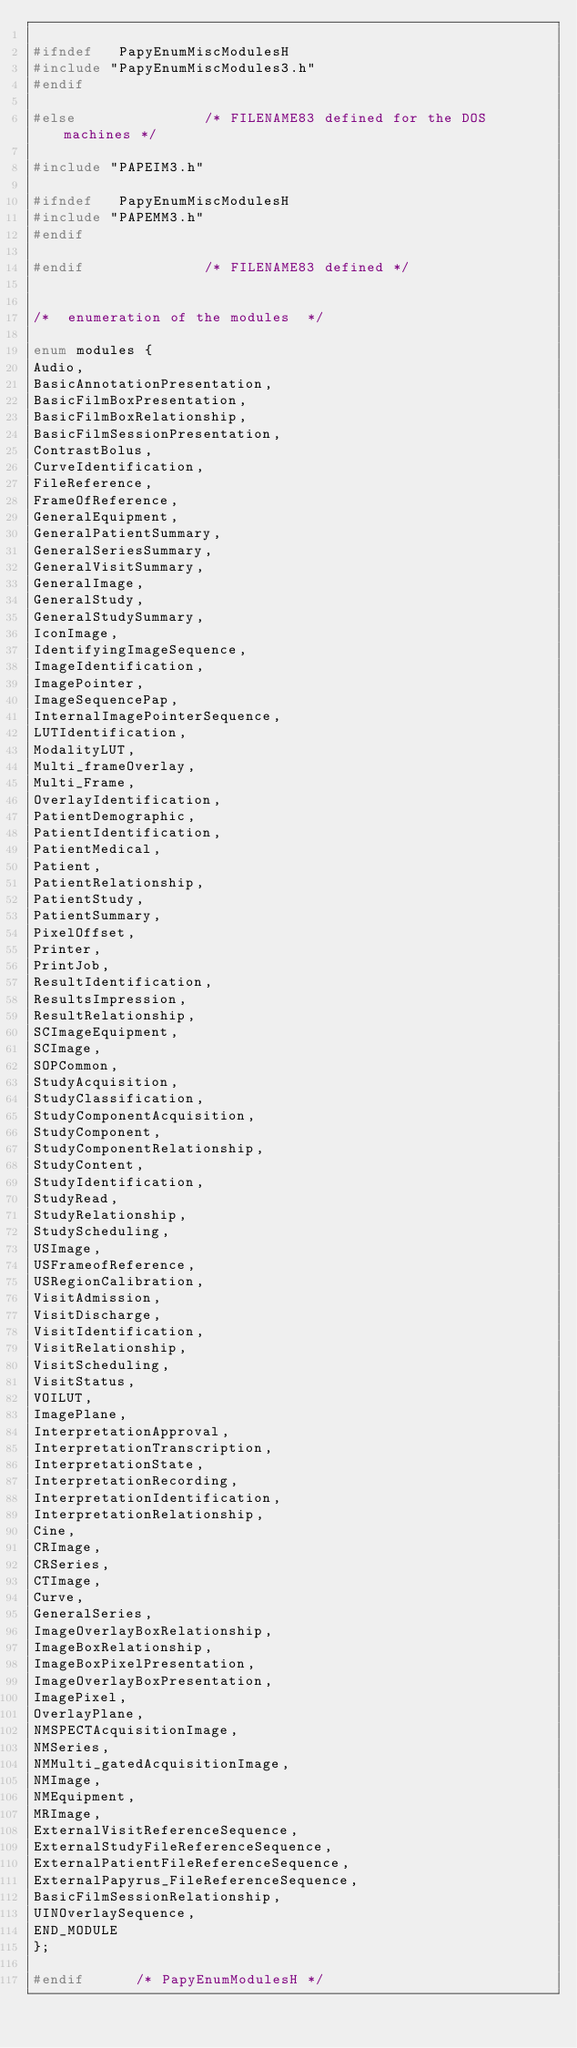Convert code to text. <code><loc_0><loc_0><loc_500><loc_500><_C_>
#ifndef   PapyEnumMiscModulesH
#include "PapyEnumMiscModules3.h"
#endif

#else				/* FILENAME83 defined for the DOS machines */

#include "PAPEIM3.h"

#ifndef   PapyEnumMiscModulesH
#include "PAPEMM3.h"
#endif

#endif 				/* FILENAME83 defined */


/* 	enumeration of the modules	*/

enum modules {
Audio,
BasicAnnotationPresentation,
BasicFilmBoxPresentation,
BasicFilmBoxRelationship,
BasicFilmSessionPresentation,
ContrastBolus,
CurveIdentification,
FileReference,
FrameOfReference,
GeneralEquipment,
GeneralPatientSummary,
GeneralSeriesSummary,
GeneralVisitSummary,
GeneralImage,
GeneralStudy,
GeneralStudySummary,
IconImage,
IdentifyingImageSequence,
ImageIdentification,
ImagePointer,
ImageSequencePap,
InternalImagePointerSequence,
LUTIdentification,
ModalityLUT,
Multi_frameOverlay,
Multi_Frame,
OverlayIdentification,
PatientDemographic,
PatientIdentification,
PatientMedical,
Patient,
PatientRelationship,
PatientStudy,
PatientSummary,
PixelOffset,
Printer,
PrintJob,
ResultIdentification,
ResultsImpression,
ResultRelationship,
SCImageEquipment,
SCImage,
SOPCommon,
StudyAcquisition,
StudyClassification,
StudyComponentAcquisition,
StudyComponent,
StudyComponentRelationship,
StudyContent,
StudyIdentification,
StudyRead,
StudyRelationship,
StudyScheduling,
USImage,
USFrameofReference,
USRegionCalibration,
VisitAdmission,
VisitDischarge,
VisitIdentification,
VisitRelationship,
VisitScheduling,
VisitStatus,
VOILUT,
ImagePlane,
InterpretationApproval,
InterpretationTranscription,
InterpretationState,
InterpretationRecording,
InterpretationIdentification,
InterpretationRelationship,
Cine,
CRImage,
CRSeries,
CTImage,
Curve,
GeneralSeries,
ImageOverlayBoxRelationship,
ImageBoxRelationship,
ImageBoxPixelPresentation,
ImageOverlayBoxPresentation,
ImagePixel,
OverlayPlane,
NMSPECTAcquisitionImage,
NMSeries,
NMMulti_gatedAcquisitionImage,
NMImage,
NMEquipment,
MRImage,
ExternalVisitReferenceSequence,
ExternalStudyFileReferenceSequence,
ExternalPatientFileReferenceSequence,
ExternalPapyrus_FileReferenceSequence,
BasicFilmSessionRelationship,
UINOverlaySequence,
END_MODULE
};

#endif	    /* PapyEnumModulesH */
</code> 